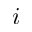<formula> <loc_0><loc_0><loc_500><loc_500>i</formula> 